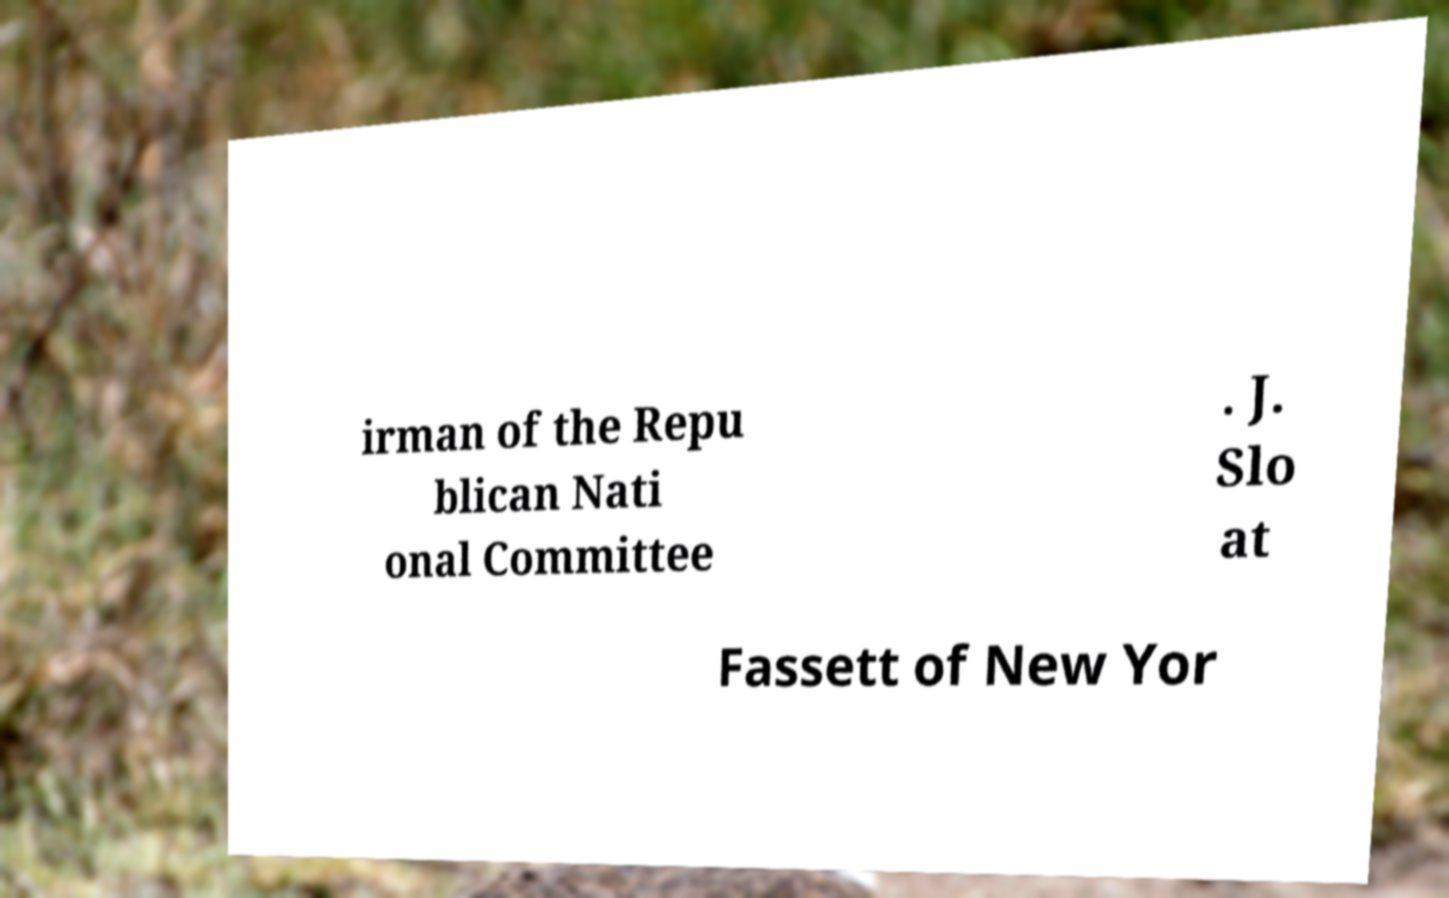Can you accurately transcribe the text from the provided image for me? irman of the Repu blican Nati onal Committee . J. Slo at Fassett of New Yor 